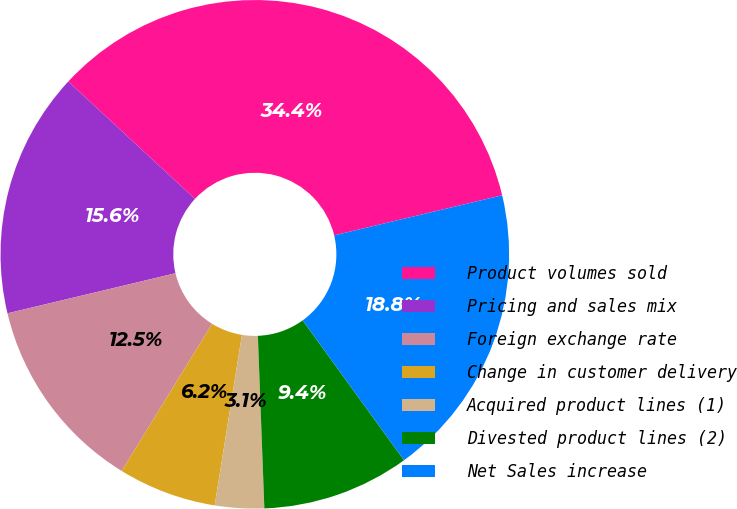<chart> <loc_0><loc_0><loc_500><loc_500><pie_chart><fcel>Product volumes sold<fcel>Pricing and sales mix<fcel>Foreign exchange rate<fcel>Change in customer delivery<fcel>Acquired product lines (1)<fcel>Divested product lines (2)<fcel>Net Sales increase<nl><fcel>34.38%<fcel>15.62%<fcel>12.5%<fcel>6.25%<fcel>3.12%<fcel>9.38%<fcel>18.75%<nl></chart> 